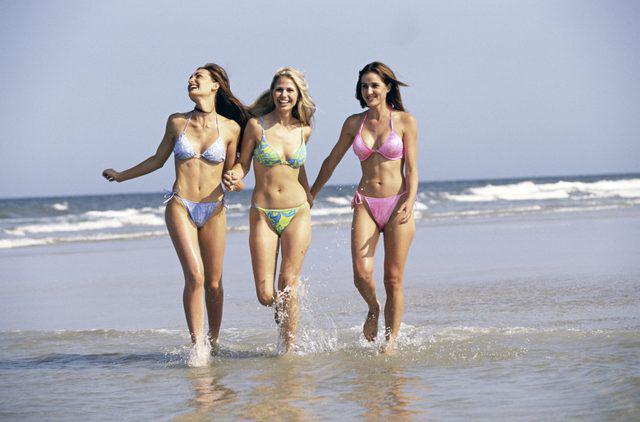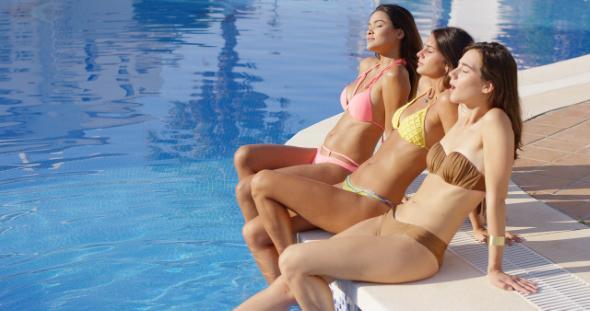The first image is the image on the left, the second image is the image on the right. Evaluate the accuracy of this statement regarding the images: "Three women are standing on the shore in the image on the left.". Is it true? Answer yes or no. Yes. The first image is the image on the left, the second image is the image on the right. For the images shown, is this caption "An image shows three standing models, each wearing a different solid-colored bikini with matching top and bottom." true? Answer yes or no. No. 